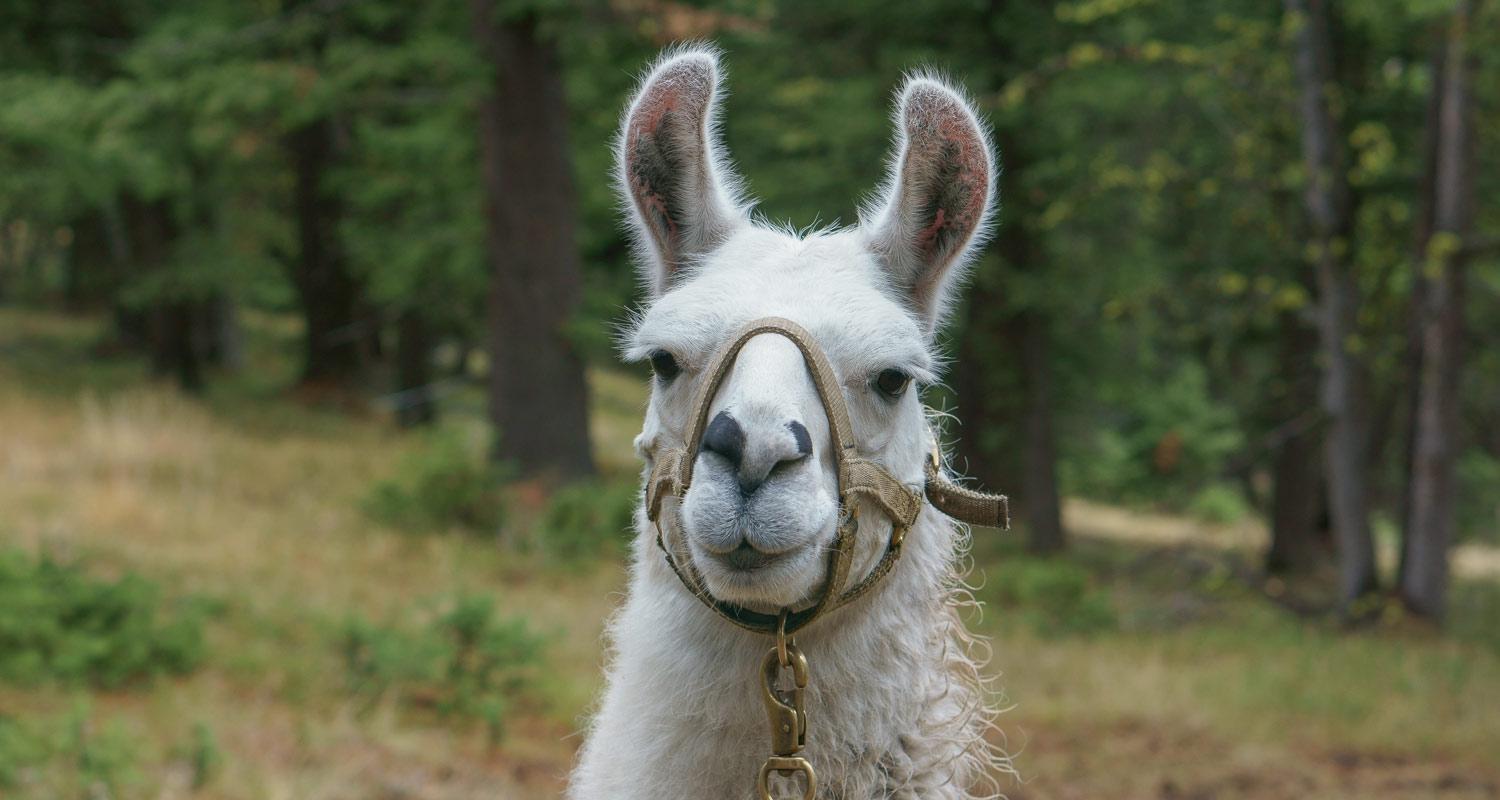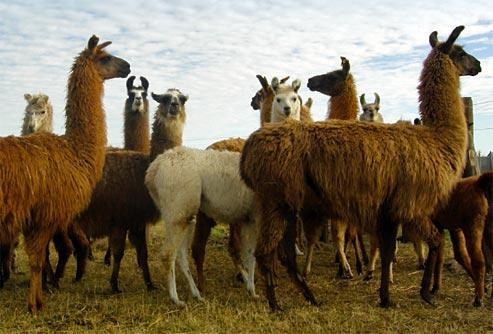The first image is the image on the left, the second image is the image on the right. Considering the images on both sides, is "There is a single alpaca in one image and multiple ones in the other." valid? Answer yes or no. Yes. The first image is the image on the left, the second image is the image on the right. For the images displayed, is the sentence "The left image features exactly one light-colored llama, and the right image shows a group of at least nine llamas, most of them standing in profile." factually correct? Answer yes or no. Yes. 